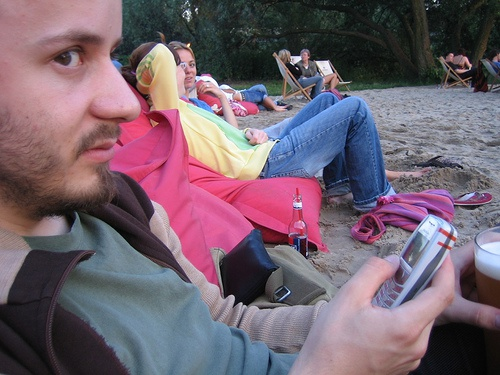Describe the objects in this image and their specific colors. I can see people in gray, darkgray, and black tones, people in gray, beige, and khaki tones, cell phone in gray and darkgray tones, handbag in gray and purple tones, and handbag in gray, black, navy, and darkblue tones in this image. 